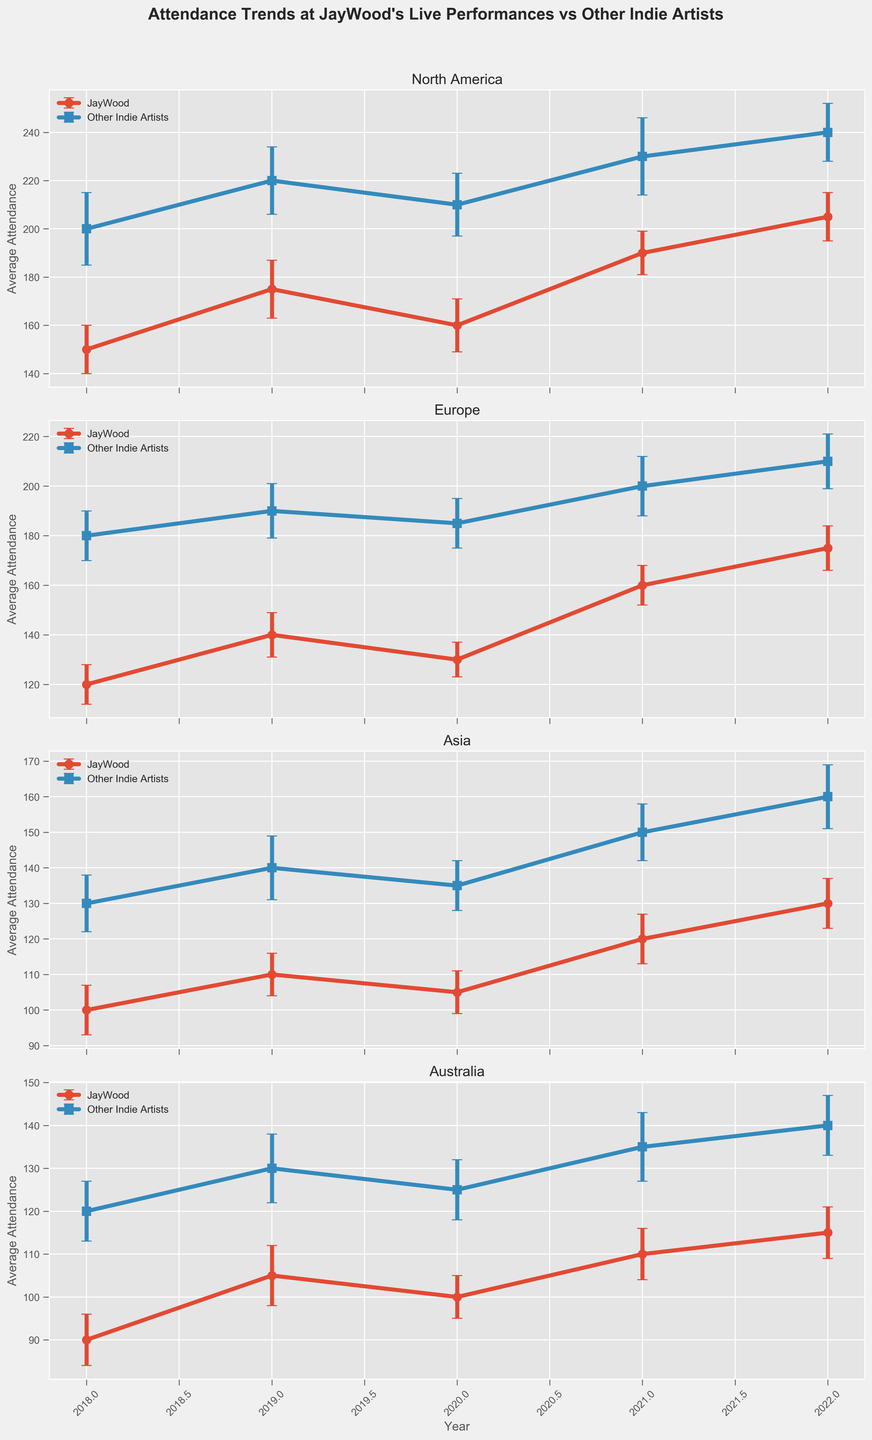How did the average attendance at JayWood's North American performances change from 2018 to 2022? To determine the change in average attendance, look at JayWood's average attendance in North America for 2018 and 2022. For 2018, it was 150, and for 2022 it was 205. Therefore, the change is calculated as 205 - 150.
Answer: 55 In 2022, how did the average attendance at JayWood's performances in Europe compare to those of other indie artists? For the year 2022 in Europe, JayWood's average attendance was 175, while other indie artists had an average attendance of 210. By comparing the two, we see that JayWood's attendance was lower.
Answer: lower Which year saw the highest average attendance for JayWood in North America? Examine the average attendance data for JayWood in North America across all years. The highest average attendance is observed in 2022 with an attendance of 205.
Answer: 2022 In which region did JayWood have the lowest average attendance in 2020? Check the average attendance figures for JayWood in 2020 for all regions. The lowest average attendance is 100 in Australia.
Answer: Australia Across all years and regions provided, how often did JayWood's performances have higher average attendance than other indie artists? Compare JayWood’s average attendance data with other indie artists' data across all years and regions. In none of the instances did JayWood's attendance surpass that of other indie artists.
Answer: 0 times Comparing the average attendance at JayWood's performances in Europe in 2021 and 2022, by how much did it change? Look at the average attendance for JayWood in Europe for the years 2021 and 2022. In 2021, it was 160, and in 2022 it was 175. The change is 175 - 160.
Answer: 15 In Asia, between which two consecutive years was there the most significant increase in average attendance for JayWood's performances? Evaluate the change in average attendance year over year for JayWood in Asia. The most significant increase is from 2020 (105) to 2021 (120), which is an increase of 15.
Answer: 2020 and 2021 What is the difference in average attendance between JayWood's 2020 performances in North America and Europe? Look at the 2020 average attendance for JayWood in North America and Europe. In North America, it was 160, and in Europe, it was 130. The difference is calculated as 160 - 130.
Answer: 30 Considering only the year 2021, in which region did JayWood’s performances have the least variance in average attendance as indicated by the smallest standard error? Compare the standard errors for all regions for JayWood's performances in 2021. The smallest standard error is 6, found in Australia.
Answer: Australia 